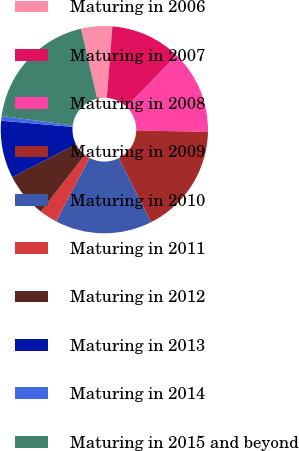Convert chart to OTSL. <chart><loc_0><loc_0><loc_500><loc_500><pie_chart><fcel>Maturing in 2006<fcel>Maturing in 2007<fcel>Maturing in 2008<fcel>Maturing in 2009<fcel>Maturing in 2010<fcel>Maturing in 2011<fcel>Maturing in 2012<fcel>Maturing in 2013<fcel>Maturing in 2014<fcel>Maturing in 2015 and beyond<nl><fcel>4.85%<fcel>11.03%<fcel>13.09%<fcel>17.21%<fcel>15.15%<fcel>2.79%<fcel>6.91%<fcel>8.97%<fcel>0.73%<fcel>19.27%<nl></chart> 